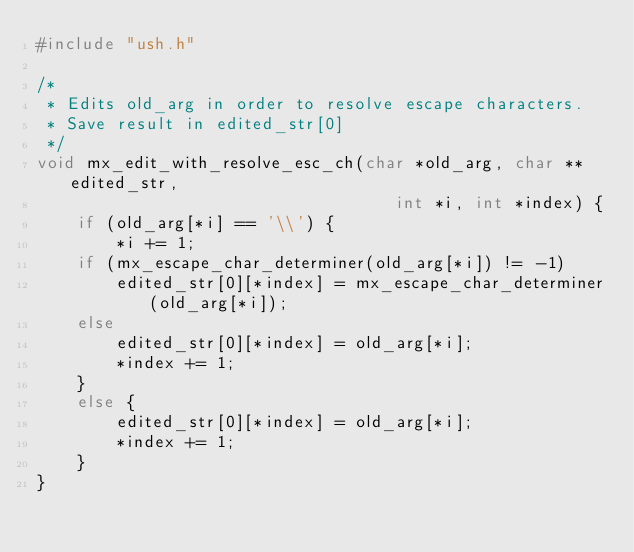<code> <loc_0><loc_0><loc_500><loc_500><_C_>#include "ush.h"

/*
 * Edits old_arg in order to resolve escape characters.
 * Save result in edited_str[0]
 */
void mx_edit_with_resolve_esc_ch(char *old_arg, char **edited_str,
                                    int *i, int *index) {
    if (old_arg[*i] == '\\') {
        *i += 1;
    if (mx_escape_char_determiner(old_arg[*i]) != -1)
        edited_str[0][*index] = mx_escape_char_determiner(old_arg[*i]);
    else
        edited_str[0][*index] = old_arg[*i];
        *index += 1;
    }
    else {
        edited_str[0][*index] = old_arg[*i];
        *index += 1;
    }
}

</code> 